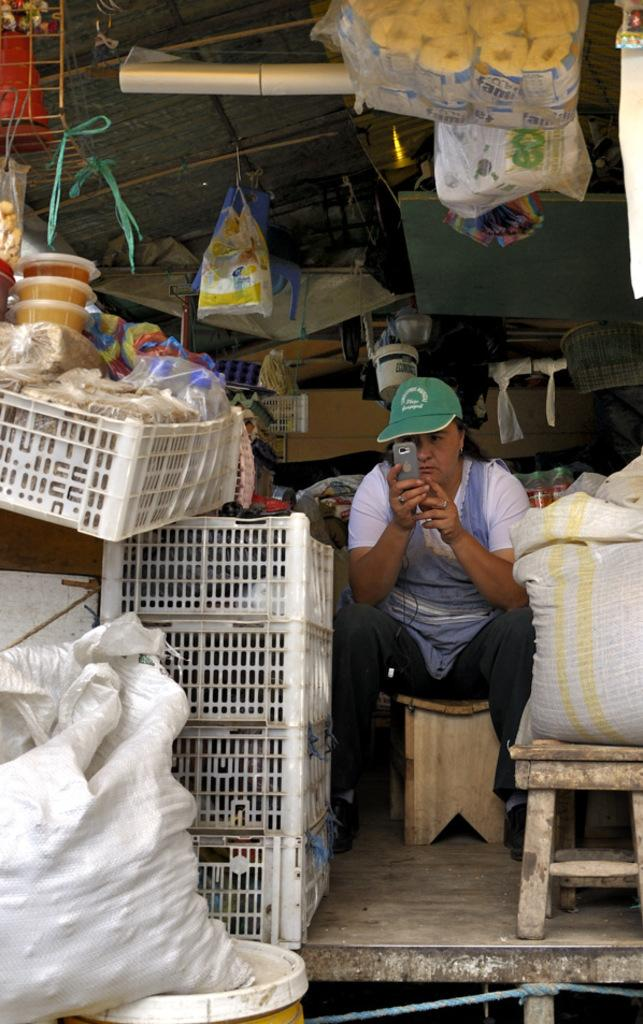What type of establishment is depicted in the image? The image appears to depict a shop. What can be seen hanging from the roof in the image? There are packets hanging from the roof in the image. What other objects are visible in the image? There are other objects visible in the image, but their specific details are not mentioned in the provided facts. What type of glass is used to make the snake in the image? There is no snake present in the image, so it is not possible to determine the type of glass used to make it. 